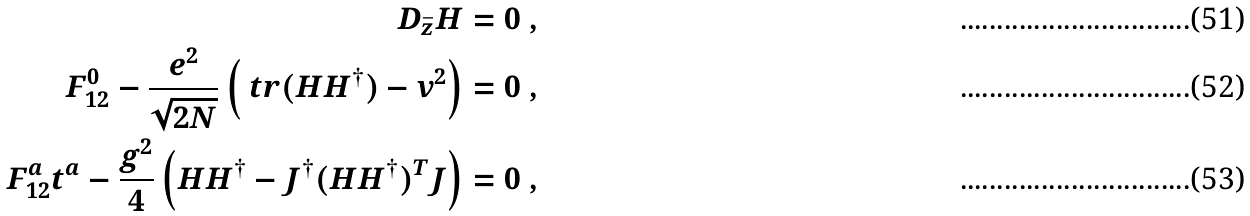Convert formula to latex. <formula><loc_0><loc_0><loc_500><loc_500>\ D _ { \bar { z } } H & = 0 \ , \\ F _ { 1 2 } ^ { 0 } - \frac { e ^ { 2 } } { \sqrt { 2 N } } \left ( \ t r ( H H ^ { \dagger } ) - v ^ { 2 } \right ) & = 0 \ , \\ F _ { 1 2 } ^ { a } t ^ { a } - \frac { g ^ { 2 } } { 4 } \left ( H H ^ { \dagger } - J ^ { \dagger } ( H H ^ { \dagger } ) ^ { T } J \right ) & = 0 \ ,</formula> 